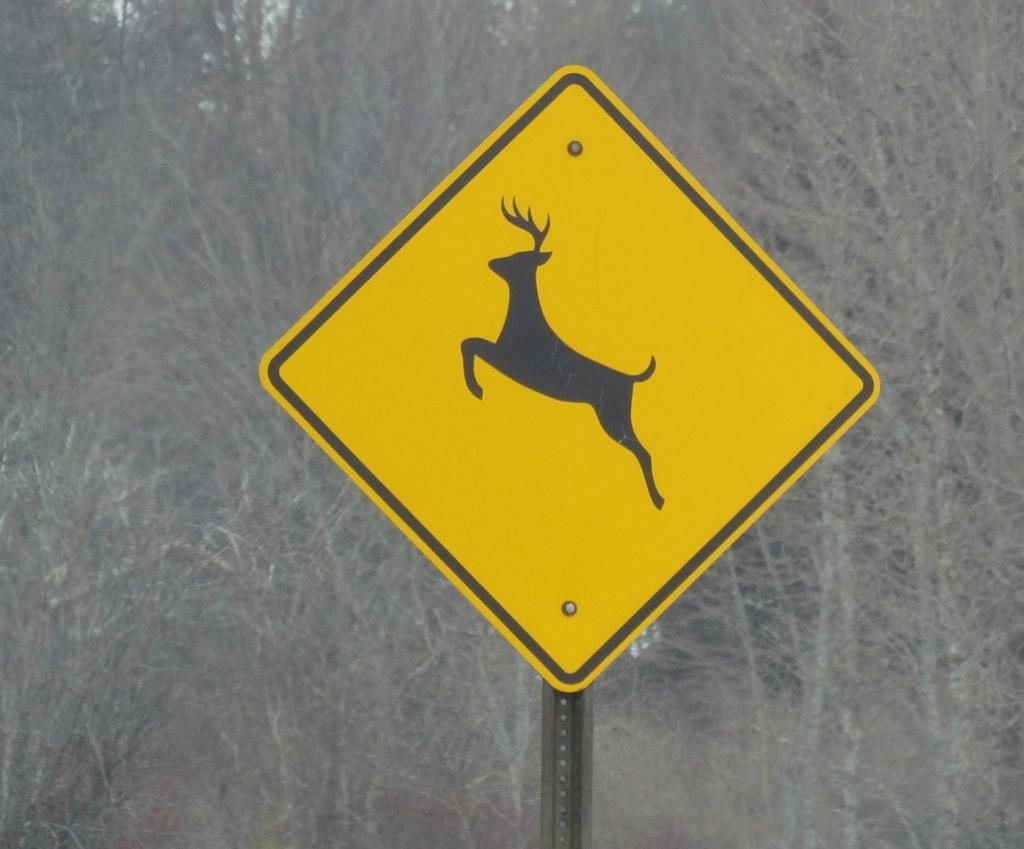What is located on the pole in the image? There is a signboard on a pole in the image. What is depicted on the signboard? The signboard has a picture on it. What can be seen in the background of the image? There is a group of trees visible on the backside of the image. What type of pickle is being held by the person in the image? There is no person present in the image, and therefore no pickle can be observed. 